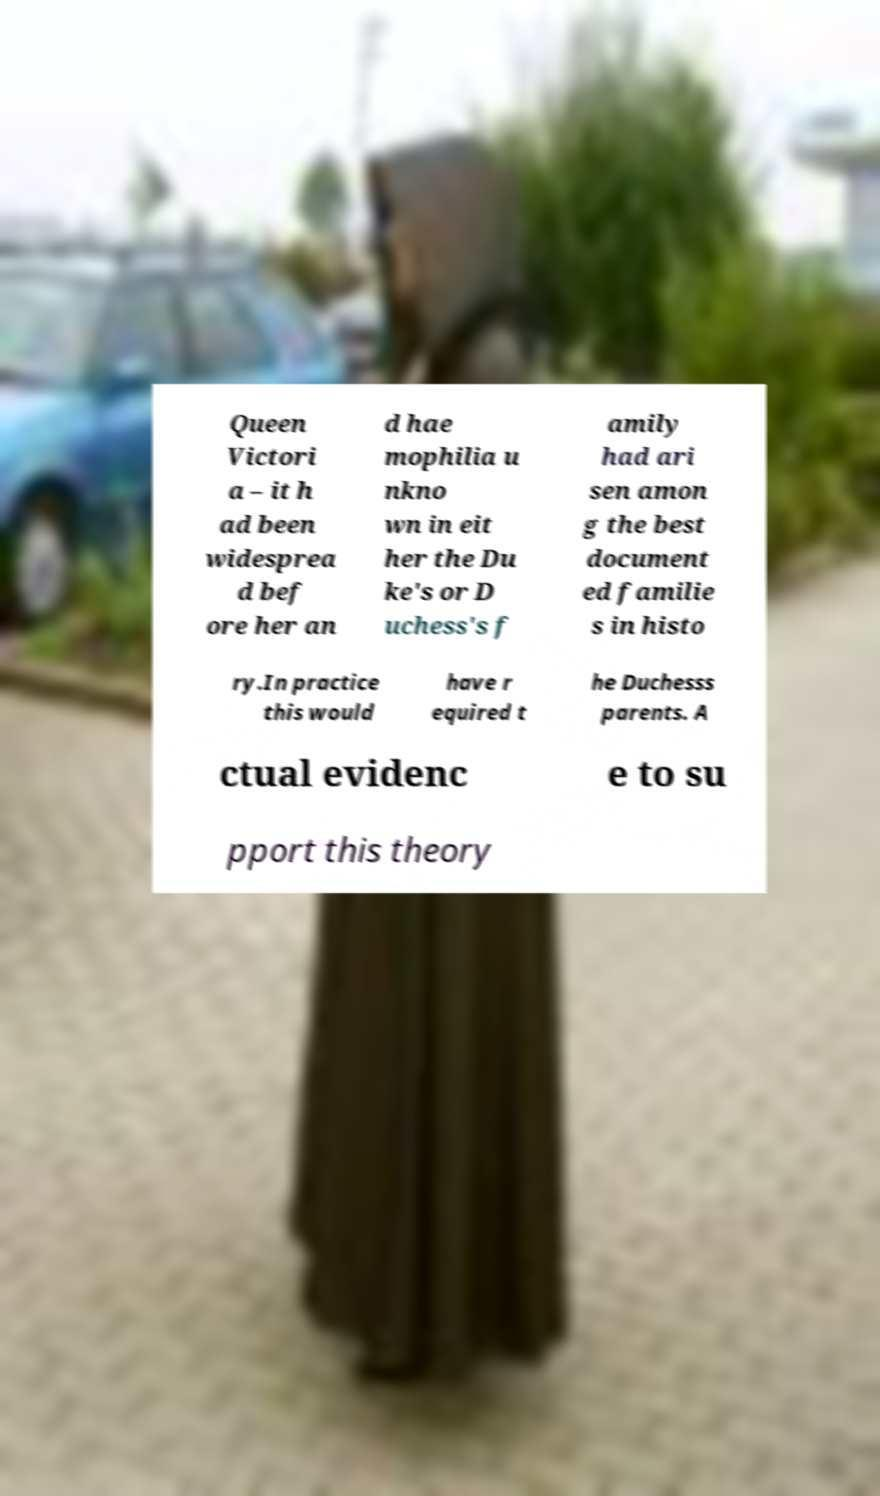There's text embedded in this image that I need extracted. Can you transcribe it verbatim? Queen Victori a – it h ad been widesprea d bef ore her an d hae mophilia u nkno wn in eit her the Du ke's or D uchess's f amily had ari sen amon g the best document ed familie s in histo ry.In practice this would have r equired t he Duchesss parents. A ctual evidenc e to su pport this theory 